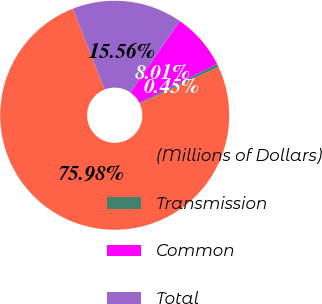Convert chart. <chart><loc_0><loc_0><loc_500><loc_500><pie_chart><fcel>(Millions of Dollars)<fcel>Transmission<fcel>Common<fcel>Total<nl><fcel>75.98%<fcel>0.45%<fcel>8.01%<fcel>15.56%<nl></chart> 